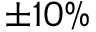<formula> <loc_0><loc_0><loc_500><loc_500>\pm 1 0 \%</formula> 